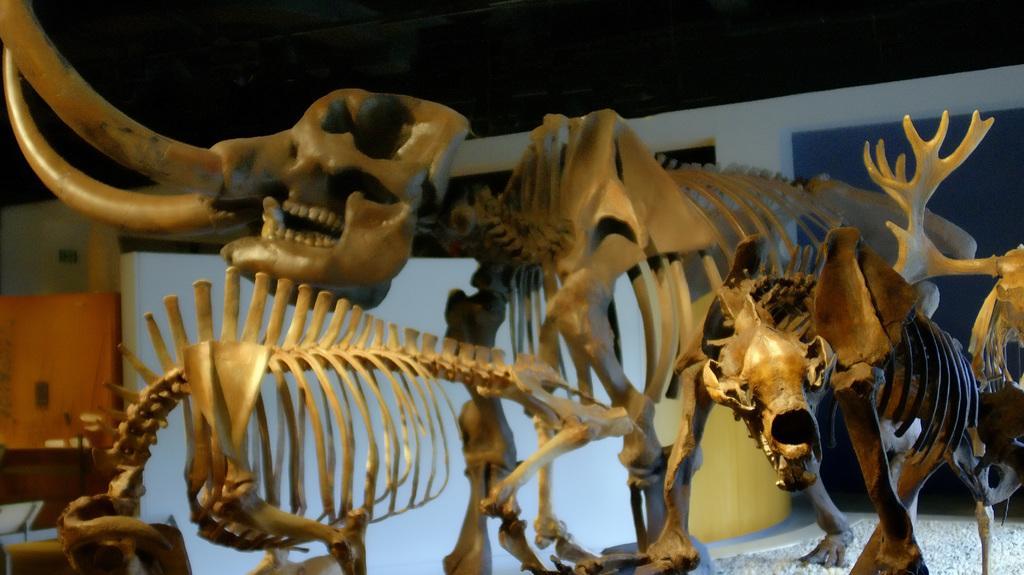How would you summarize this image in a sentence or two? In this picture I can see few animal skeletons and looks like a wall on the left side and it looks like inner view of a room. 